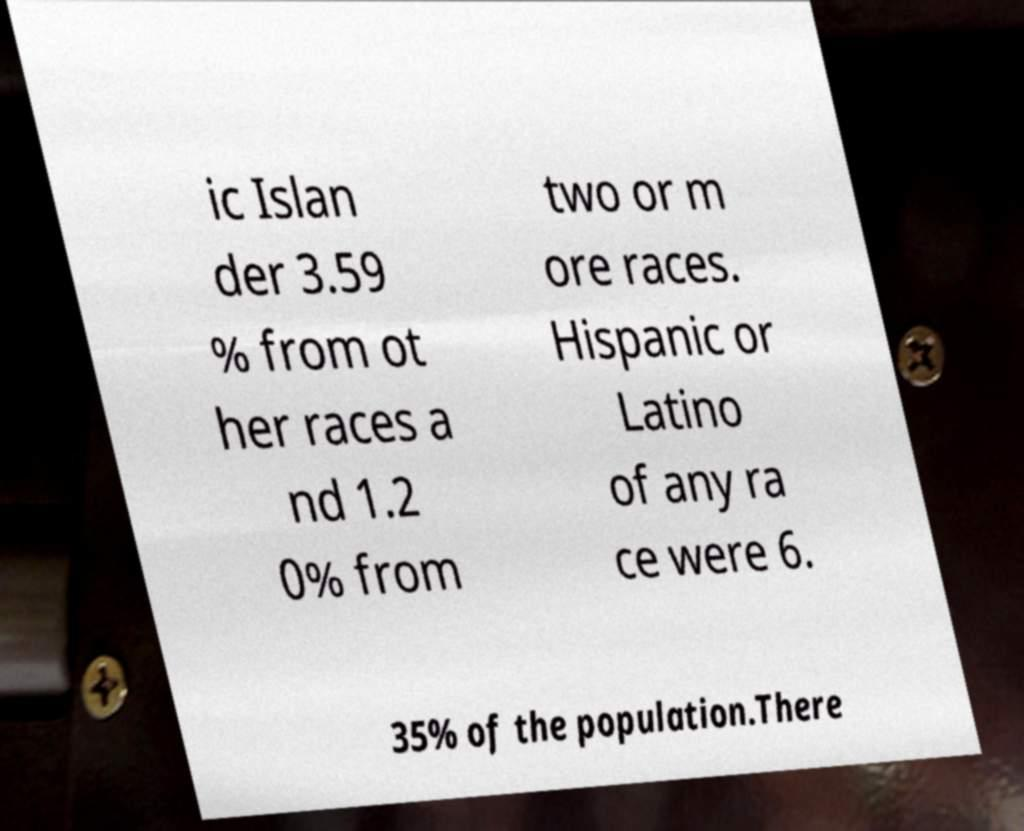Could you extract and type out the text from this image? ic Islan der 3.59 % from ot her races a nd 1.2 0% from two or m ore races. Hispanic or Latino of any ra ce were 6. 35% of the population.There 